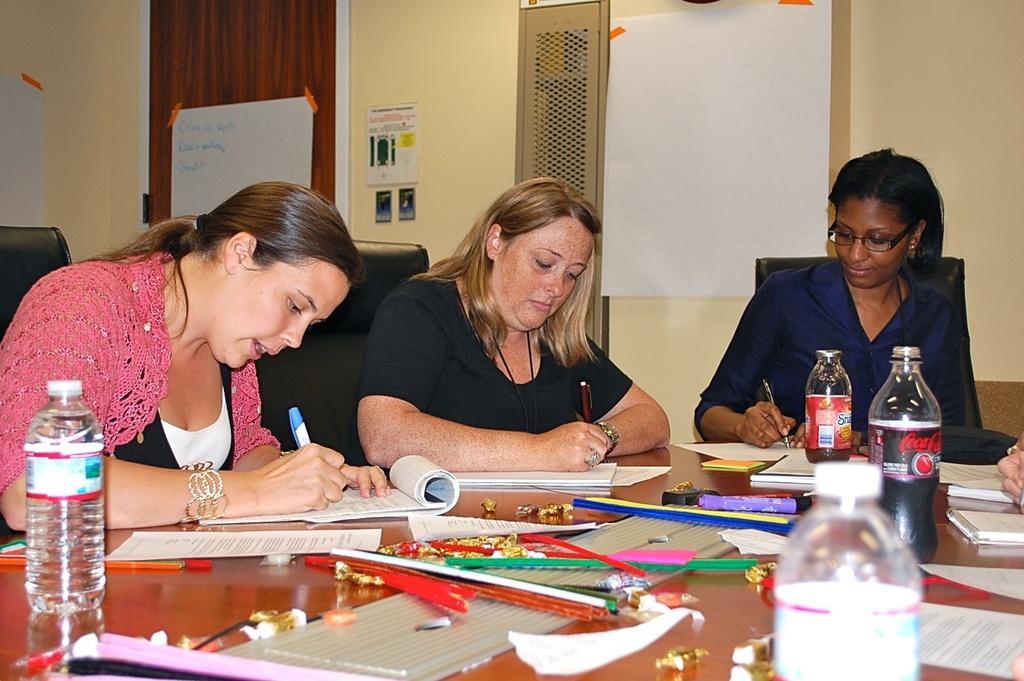Can you describe this image briefly? In this image we can see three women sitting on a chair and they are writing on a paper. This is a wooden table where a bottle and a cool drink and sketches are kept on it. 